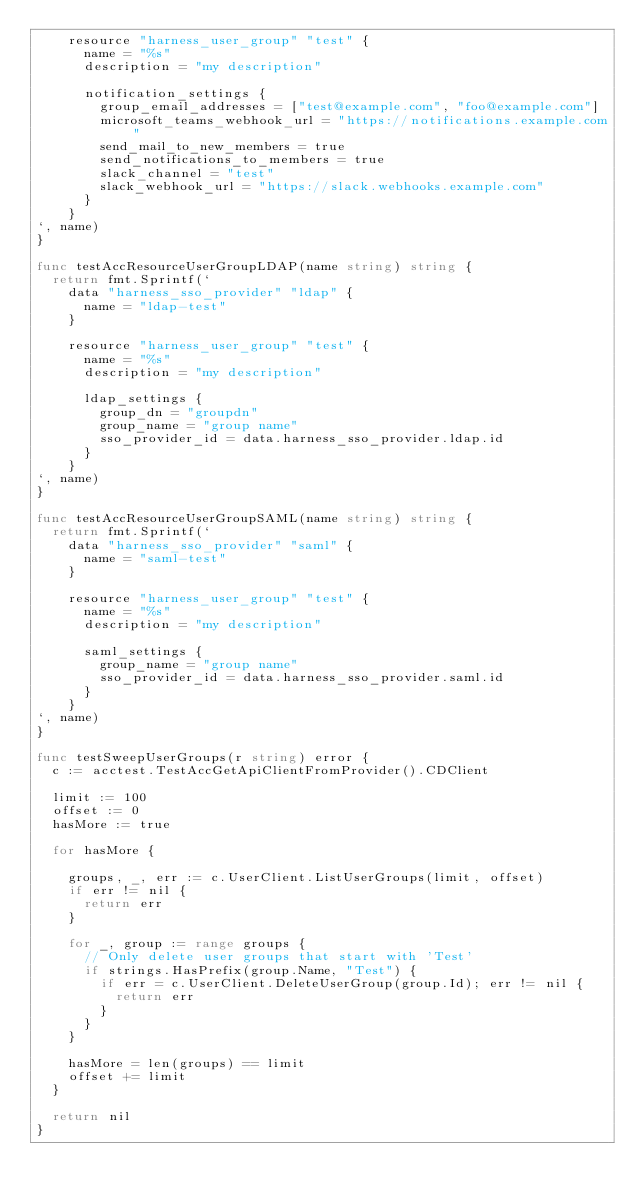Convert code to text. <code><loc_0><loc_0><loc_500><loc_500><_Go_>		resource "harness_user_group" "test" {
			name = "%s"
			description = "my description"

			notification_settings {
				group_email_addresses = ["test@example.com", "foo@example.com"]
				microsoft_teams_webhook_url = "https://notifications.example.com"
				send_mail_to_new_members = true
				send_notifications_to_members = true
				slack_channel = "test"
				slack_webhook_url = "https://slack.webhooks.example.com"
			}
		}
`, name)
}

func testAccResourceUserGroupLDAP(name string) string {
	return fmt.Sprintf(`
	  data "harness_sso_provider" "ldap" {
			name = "ldap-test"
		}

		resource "harness_user_group" "test" {
			name = "%s"
			description = "my description"

			ldap_settings {
				group_dn = "groupdn"
				group_name = "group name"
				sso_provider_id = data.harness_sso_provider.ldap.id
			}
		}
`, name)
}

func testAccResourceUserGroupSAML(name string) string {
	return fmt.Sprintf(`
	  data "harness_sso_provider" "saml" {
			name = "saml-test"
		}

		resource "harness_user_group" "test" {
			name = "%s"
			description = "my description"

			saml_settings {
				group_name = "group name"
				sso_provider_id = data.harness_sso_provider.saml.id
			}
		}
`, name)
}

func testSweepUserGroups(r string) error {
	c := acctest.TestAccGetApiClientFromProvider().CDClient

	limit := 100
	offset := 0
	hasMore := true

	for hasMore {

		groups, _, err := c.UserClient.ListUserGroups(limit, offset)
		if err != nil {
			return err
		}

		for _, group := range groups {
			// Only delete user groups that start with 'Test'
			if strings.HasPrefix(group.Name, "Test") {
				if err = c.UserClient.DeleteUserGroup(group.Id); err != nil {
					return err
				}
			}
		}

		hasMore = len(groups) == limit
		offset += limit
	}

	return nil
}
</code> 